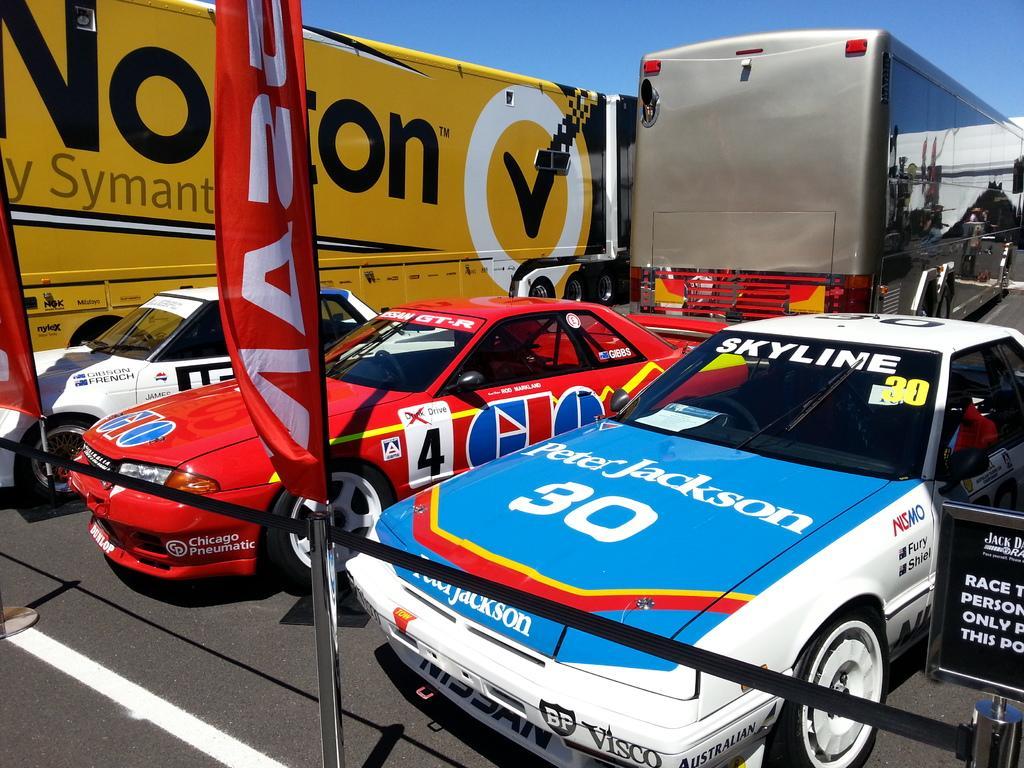How would you summarize this image in a sentence or two? In the image we can see there are vehicles of different colors. Here we can see a road and white lines on the road. Here we can see a board, on the board there is a text. We can even see the flag and pale blue sky. 